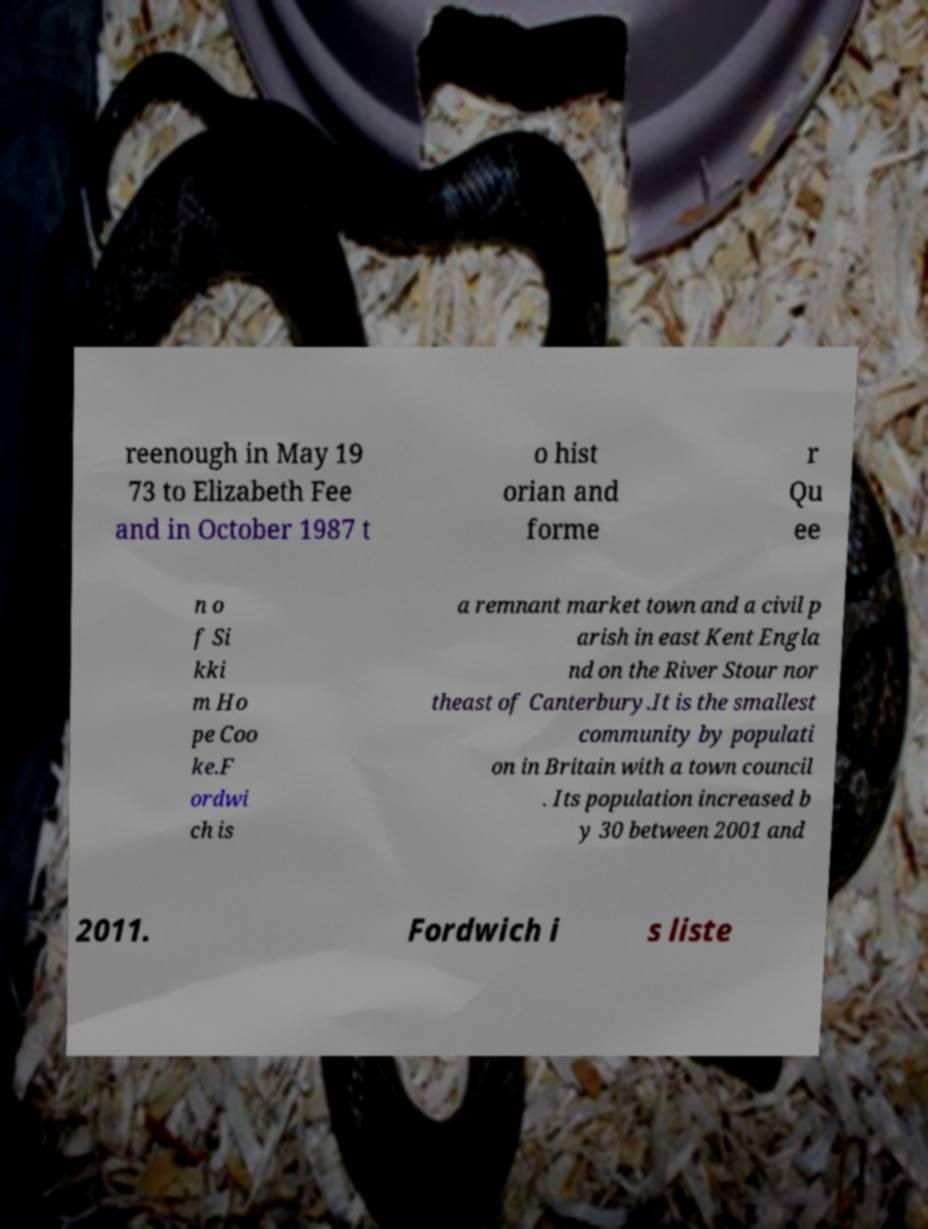What messages or text are displayed in this image? I need them in a readable, typed format. reenough in May 19 73 to Elizabeth Fee and in October 1987 t o hist orian and forme r Qu ee n o f Si kki m Ho pe Coo ke.F ordwi ch is a remnant market town and a civil p arish in east Kent Engla nd on the River Stour nor theast of Canterbury.It is the smallest community by populati on in Britain with a town council . Its population increased b y 30 between 2001 and 2011. Fordwich i s liste 